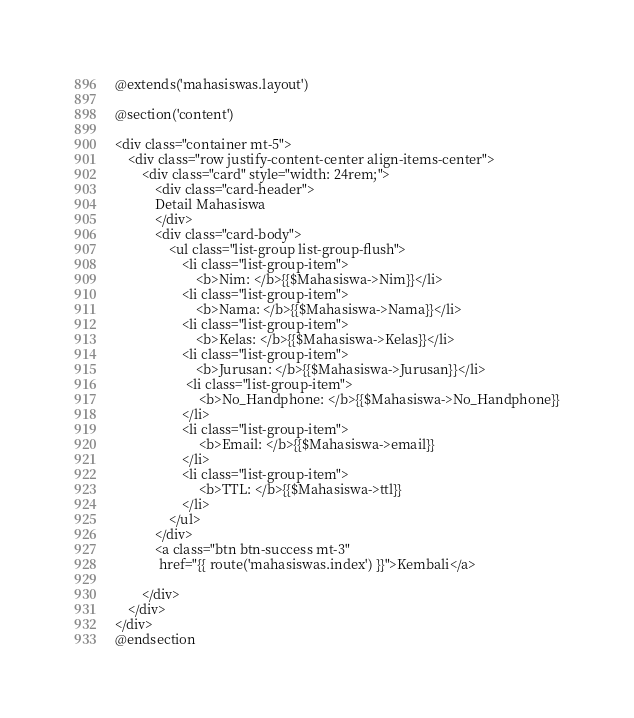<code> <loc_0><loc_0><loc_500><loc_500><_PHP_>@extends('mahasiswas.layout')
  
@section('content')

<div class="container mt-5">
    <div class="row justify-content-center align-items-center">
        <div class="card" style="width: 24rem;">
            <div class="card-header">
            Detail Mahasiswa
            </div>
            <div class="card-body">
                <ul class="list-group list-group-flush">
                    <li class="list-group-item">
                        <b>Nim: </b>{{$Mahasiswa->Nim}}</li>
                    <li class="list-group-item">
                        <b>Nama: </b>{{$Mahasiswa->Nama}}</li>
                    <li class="list-group-item">
                        <b>Kelas: </b>{{$Mahasiswa->Kelas}}</li>
                    <li class="list-group-item">
                        <b>Jurusan: </b>{{$Mahasiswa->Jurusan}}</li>
                     <li class="list-group-item">
                         <b>No_Handphone: </b>{{$Mahasiswa->No_Handphone}}
                    </li>
                    <li class="list-group-item">
                         <b>Email: </b>{{$Mahasiswa->email}}
                    </li>
                    <li class="list-group-item">
                         <b>TTL: </b>{{$Mahasiswa->ttl}}
                    </li>
                </ul>
            </div>
            <a class="btn btn-success mt-3"
             href="{{ route('mahasiswas.index') }}">Kembali</a>

        </div>
    </div>
</div>
@endsection
</code> 